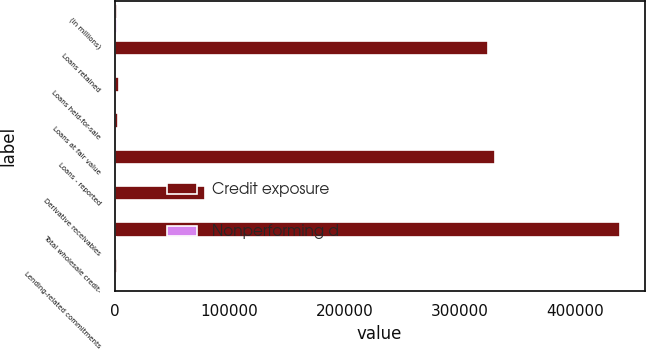Convert chart. <chart><loc_0><loc_0><loc_500><loc_500><stacked_bar_chart><ecel><fcel>(in millions)<fcel>Loans retained<fcel>Loans held-for-sale<fcel>Loans at fair value<fcel>Loans - reported<fcel>Derivative receivables<fcel>Total wholesale credit-<fcel>Lending-related commitments<nl><fcel>Credit exposure<fcel>2014<fcel>324502<fcel>3801<fcel>2611<fcel>330914<fcel>78975<fcel>438861<fcel>2014<nl><fcel>Nonperforming d<fcel>2014<fcel>599<fcel>4<fcel>21<fcel>624<fcel>275<fcel>899<fcel>103<nl></chart> 